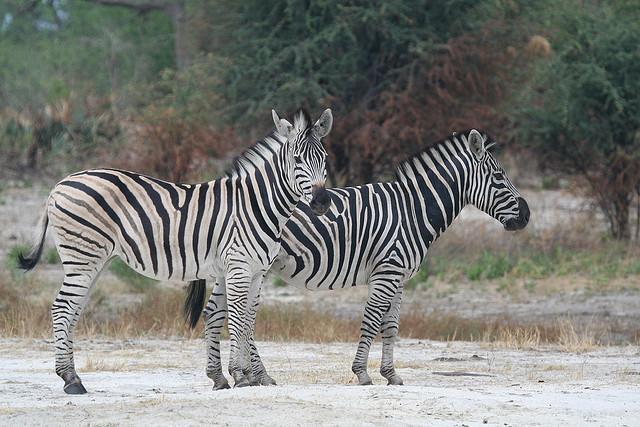How many zebras are there?
Give a very brief answer. 2. How many animals here?
Give a very brief answer. 2. How many zebras are laying down?
Give a very brief answer. 0. How many zebras can be seen?
Give a very brief answer. 2. How many horses are there?
Give a very brief answer. 0. 